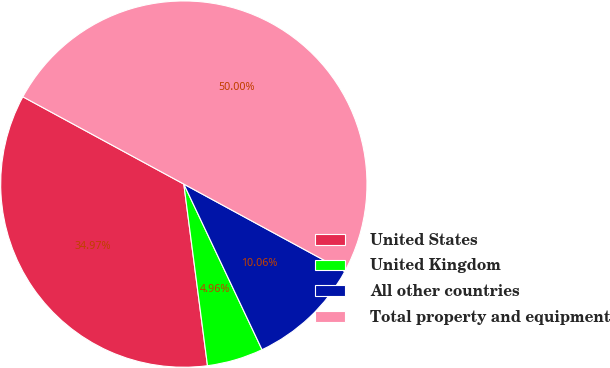Convert chart to OTSL. <chart><loc_0><loc_0><loc_500><loc_500><pie_chart><fcel>United States<fcel>United Kingdom<fcel>All other countries<fcel>Total property and equipment<nl><fcel>34.97%<fcel>4.96%<fcel>10.06%<fcel>50.0%<nl></chart> 